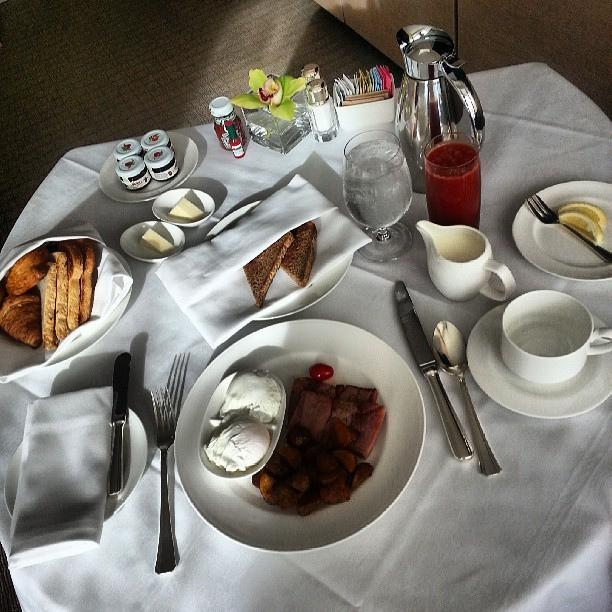When is the type of meal above favorable to be served?

Choices:
A) afternoon
B) supper
C) breakfast
D) lunch breakfast 